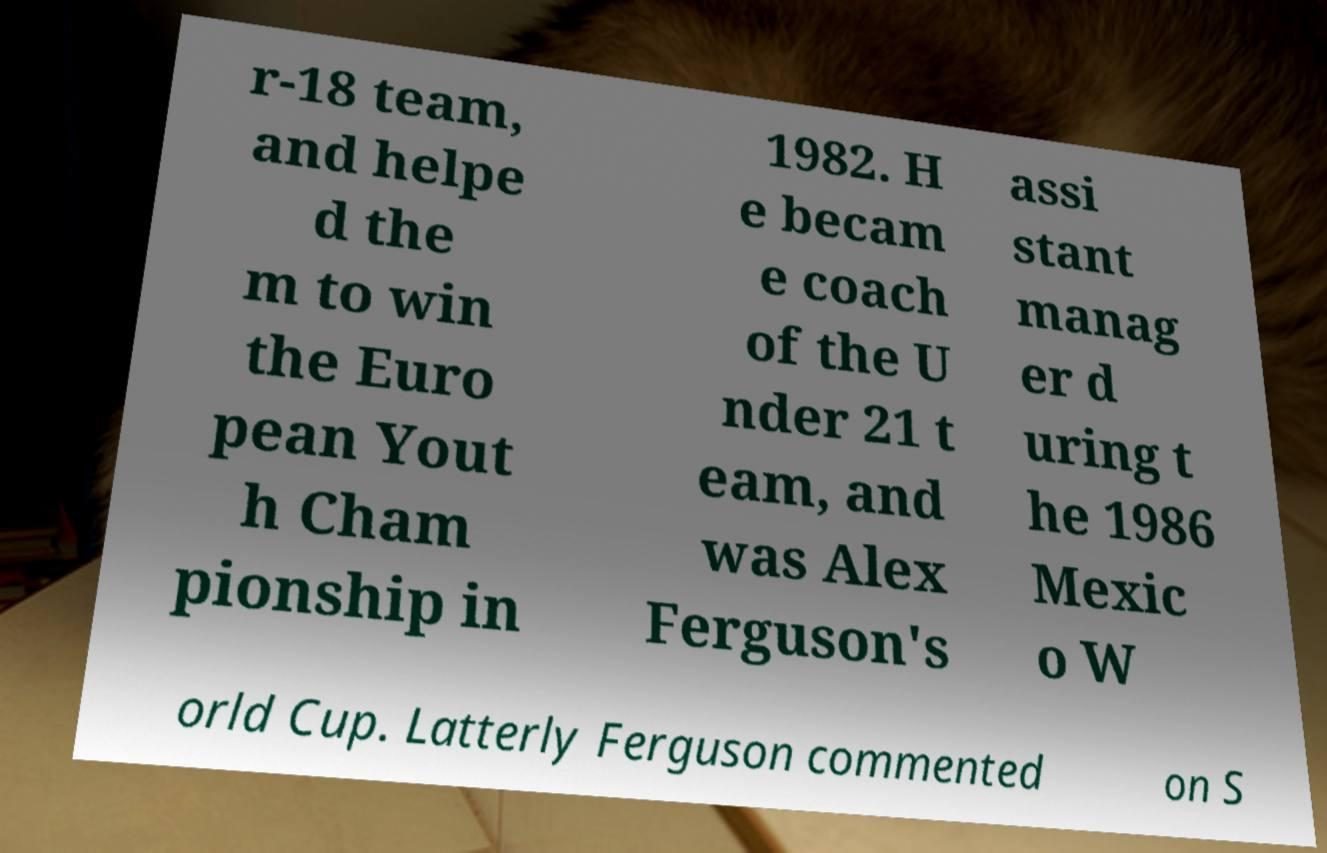Can you accurately transcribe the text from the provided image for me? r-18 team, and helpe d the m to win the Euro pean Yout h Cham pionship in 1982. H e becam e coach of the U nder 21 t eam, and was Alex Ferguson's assi stant manag er d uring t he 1986 Mexic o W orld Cup. Latterly Ferguson commented on S 